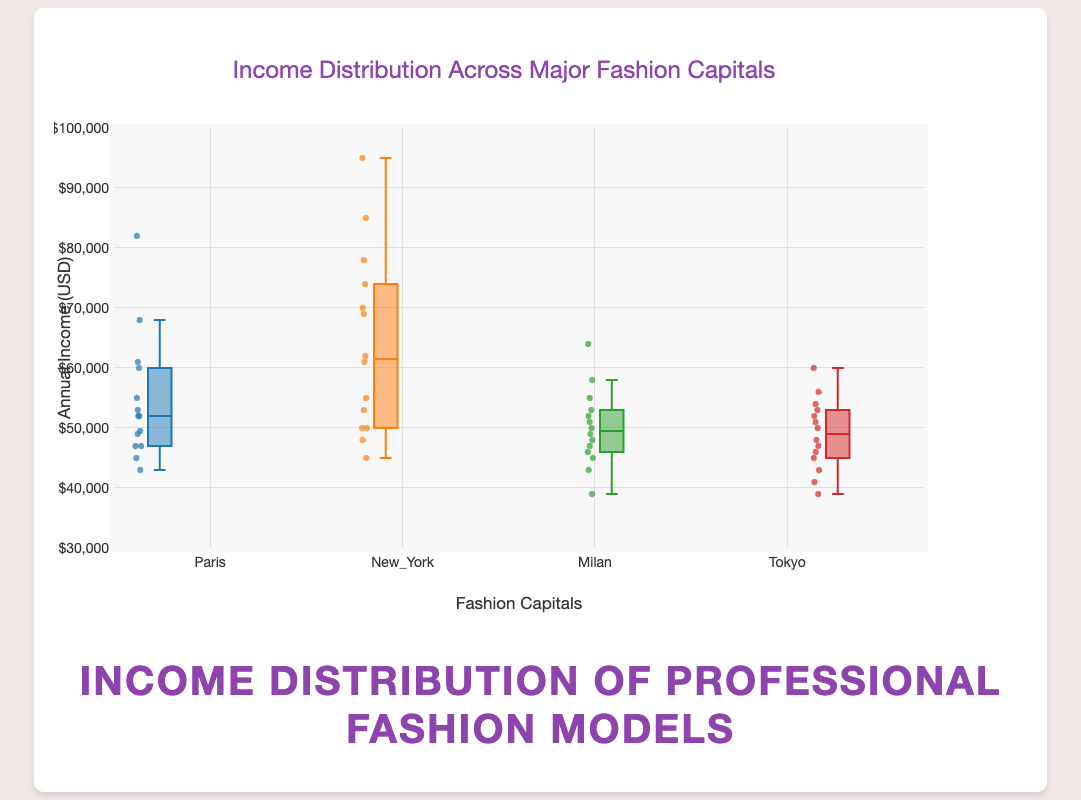What is the general title of the figure? The title of a figure is usually displayed prominently at the top and helps the viewer understand the main theme or subject of the graph. Here, it reads "Income Distribution of Professional Fashion Models."
Answer: Income Distribution of Professional Fashion Models What does the y-axis represent in the figure? The y-axis shows the range and units of measurement for the data being displayed. In this figure, it represents the "Annual Income (USD)."
Answer: Annual Income (USD) Which fashion capital has the widest range of income distribution based on the box plot? To find the widest range, observe the box plot's whiskers, which extend from the minimum to the maximum values. New York's box plot has the widest range from the lowest to highest point.
Answer: New York What is the median income for fashion models in Milan? In a box plot, the median is indicated by the line inside the box. By locating the median line in Milan's box, the approximate median income can be found around $50,000.
Answer: $50,000 How does the median income of fashion models in Tokyo compare with that in Paris? Compare the medians indicated by the lines inside the boxes for both Tokyo and Paris. Tokyo's median income line (around $48,000) is slightly lower than that of Paris (around $52,000).
Answer: Tokyo's median is slightly lower Which city has the highest outliers in income distribution? Outliers are indicated by points that lie outside the whiskers of the box plot. New York has the highest income outliers.
Answer: New York What is the interquartile range (IQR) for Paris? The IQR is the range between the first quartile (Q1) and the third quartile (Q3). For Paris, identify the lower (Q1, $47,000) and upper (Q3, $61,000) edges of the box. The IQR is $61,000 - $47,000 = $14,000.
Answer: $14,000 How does the variability of income in Milan compare to Tokyo? Variability is indicated by the length of the boxes and whiskers. Milan has a slightly longer box and whiskers compared to Tokyo, suggesting more variability.
Answer: More variable Which fashion capital has the highest median income for fashion models? Observe the line inside each box that represents the median. New York has the highest median income among the cities.
Answer: New York Is the median income for fashion models in Paris higher than the first quartile income in New York? The first quartile (Q1) for New York is found at the lower edge of the box (around $50,000), and Paris's median is approximately $52,000. Since $52,000 > $50,000, Paris's median is higher.
Answer: Yes 